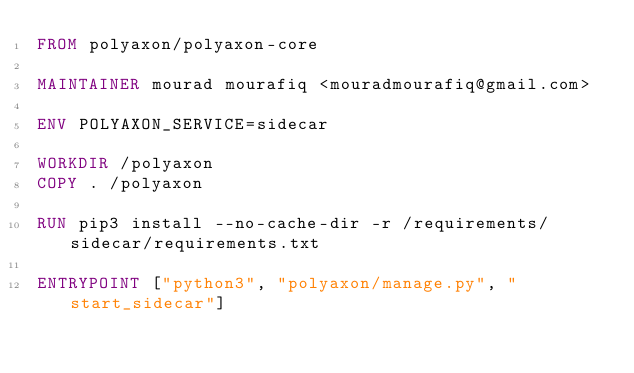Convert code to text. <code><loc_0><loc_0><loc_500><loc_500><_Dockerfile_>FROM polyaxon/polyaxon-core

MAINTAINER mourad mourafiq <mouradmourafiq@gmail.com>

ENV POLYAXON_SERVICE=sidecar

WORKDIR /polyaxon
COPY . /polyaxon

RUN pip3 install --no-cache-dir -r /requirements/sidecar/requirements.txt

ENTRYPOINT ["python3", "polyaxon/manage.py", "start_sidecar"]
</code> 